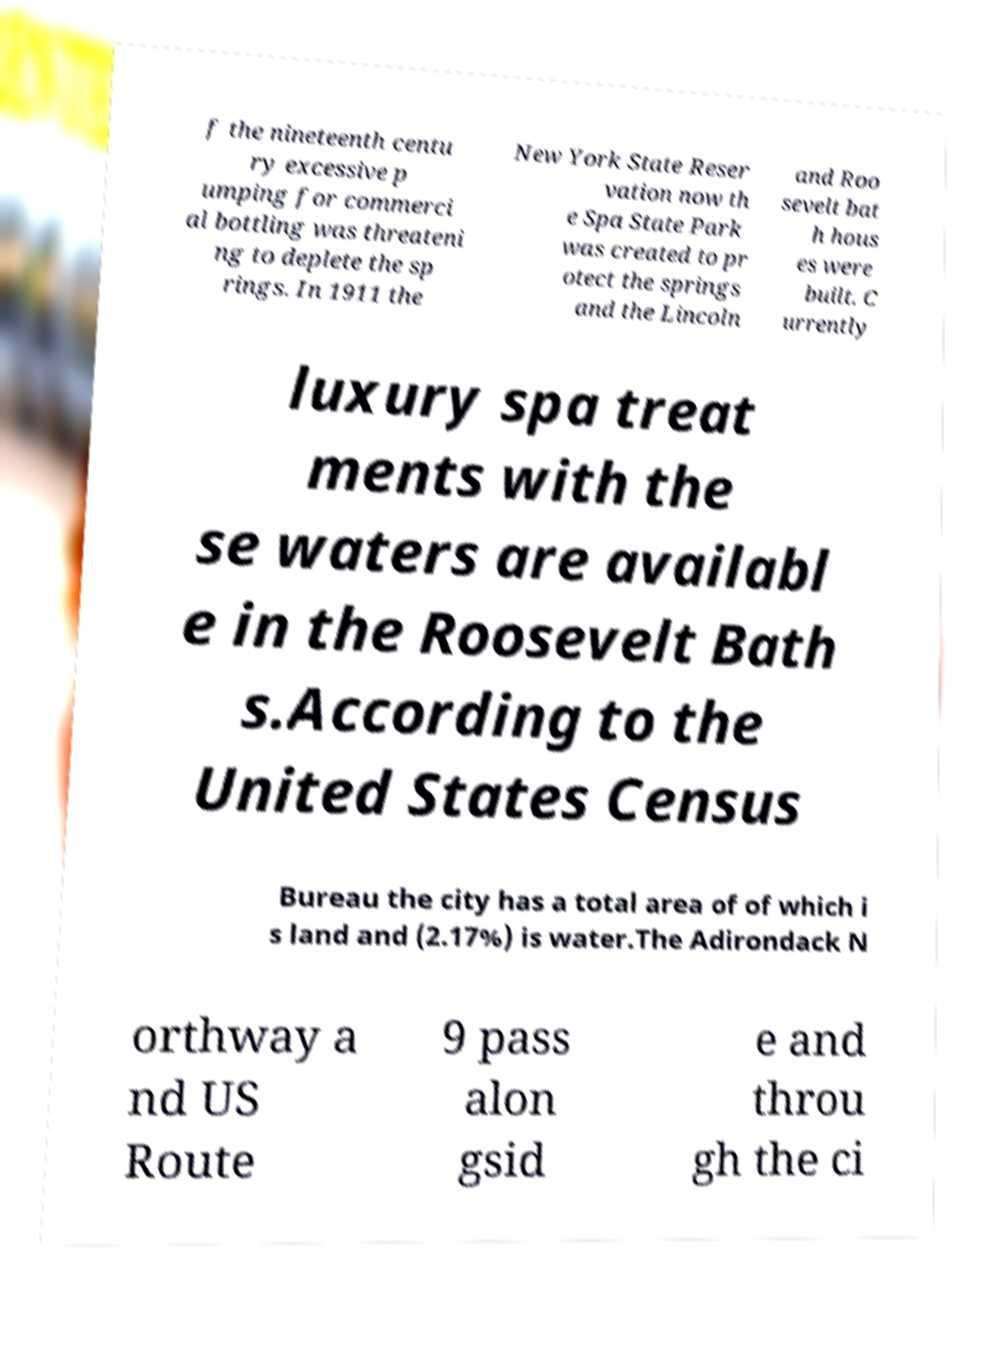I need the written content from this picture converted into text. Can you do that? f the nineteenth centu ry excessive p umping for commerci al bottling was threateni ng to deplete the sp rings. In 1911 the New York State Reser vation now th e Spa State Park was created to pr otect the springs and the Lincoln and Roo sevelt bat h hous es were built. C urrently luxury spa treat ments with the se waters are availabl e in the Roosevelt Bath s.According to the United States Census Bureau the city has a total area of of which i s land and (2.17%) is water.The Adirondack N orthway a nd US Route 9 pass alon gsid e and throu gh the ci 